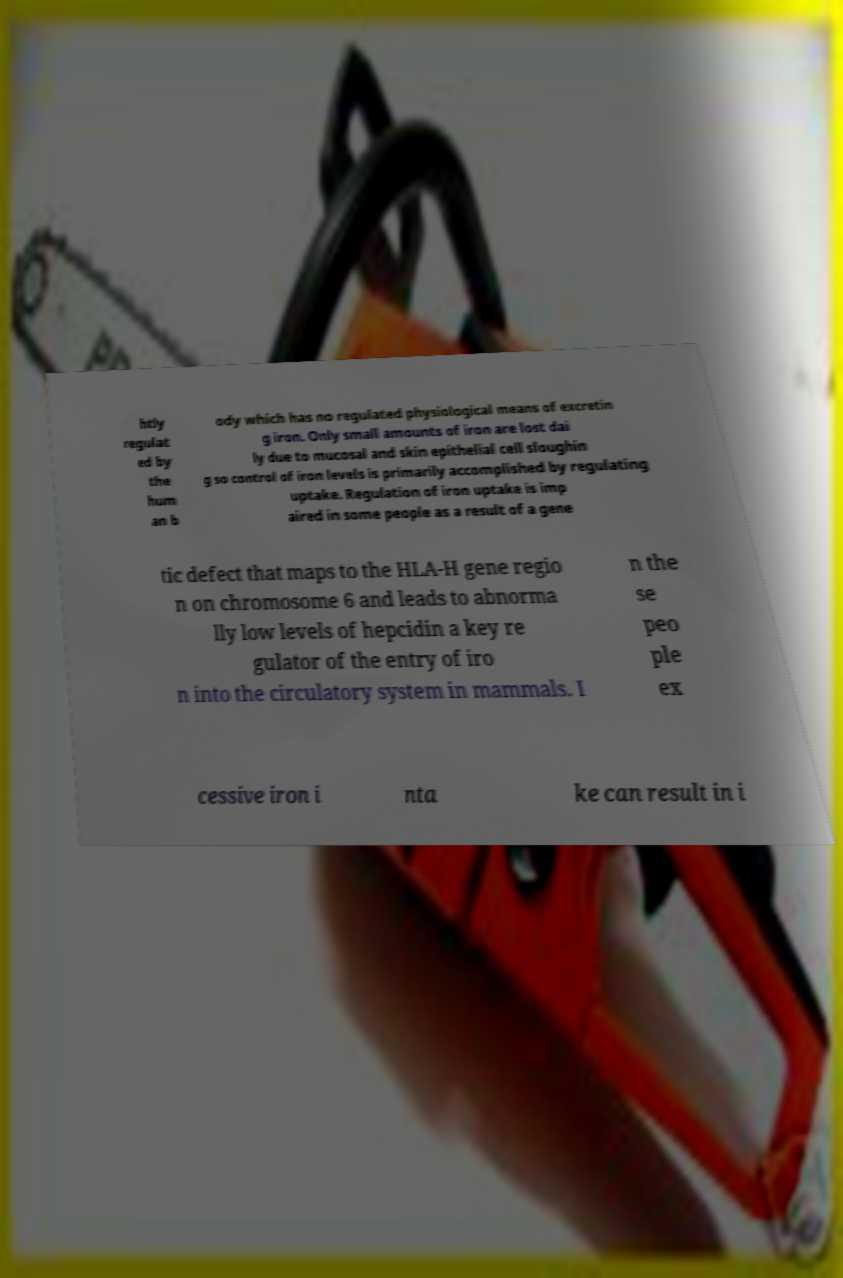Could you assist in decoding the text presented in this image and type it out clearly? htly regulat ed by the hum an b ody which has no regulated physiological means of excretin g iron. Only small amounts of iron are lost dai ly due to mucosal and skin epithelial cell sloughin g so control of iron levels is primarily accomplished by regulating uptake. Regulation of iron uptake is imp aired in some people as a result of a gene tic defect that maps to the HLA-H gene regio n on chromosome 6 and leads to abnorma lly low levels of hepcidin a key re gulator of the entry of iro n into the circulatory system in mammals. I n the se peo ple ex cessive iron i nta ke can result in i 